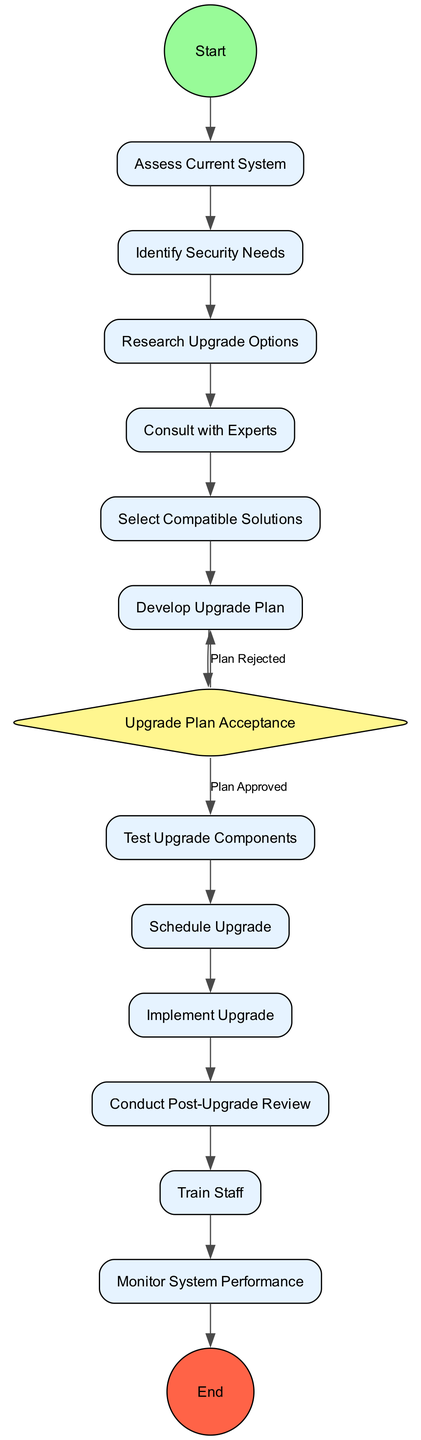What is the first step in the upgrade process? The first step in the upgrade process is represented by the "Start" node, which leads to the "Assess Current System" activity. This indicates that assessing the existing system is the initial action to take.
Answer: Assess Current System How many activities are listed in the diagram? Counting each of the nodes that represent activities gives a total of 12 activities identified in the diagram.
Answer: 12 What is the final activity before reaching the "End"? The final activity that leads to the "End" is "Monitor System Performance," as it is the last connected node before the termination of the process.
Answer: Monitor System Performance What decision must be made after developing the upgrade plan? After developing the upgrade plan, a decision must be made regarding the acceptance of the plan, specifically whether it meets the criteria for security, privacy, and minimal disruption.
Answer: Upgrade Plan Acceptance Which activity follows the "Consult with Experts"? Following the "Consult with Experts" activity, the next step in the process is "Select Compatible Solutions," which shows a logical progression in the context of the diagram.
Answer: Select Compatible Solutions If the upgrade plan is rejected, which step do you return to? If the upgrade plan is rejected, the process flows back to "Develop Upgrade Plan," indicating that the plan needs to be reworked or further refined.
Answer: Develop Upgrade Plan What is the condition for moving from "Upgrade Plan Acceptance" to "Test Upgrade Components"? The condition for transitioning from "Upgrade Plan Acceptance" to "Test Upgrade Components" is that the plan has to be approved, indicating a successful review of the proposed changes.
Answer: Plan Approved How is the "Train Staff" activity related to the "Conduct Post-Upgrade Review"? The "Train Staff" activity follows directly after the "Conduct Post-Upgrade Review," indicating that training occurs after the review of the upgrade's effectiveness.
Answer: Directly follows 